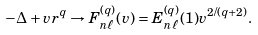<formula> <loc_0><loc_0><loc_500><loc_500>- \Delta + v r ^ { q } \rightarrow F _ { n \ell } ^ { ( q ) } ( v ) = E _ { n \ell } ^ { ( q ) } ( 1 ) v ^ { 2 / ( q + 2 ) } .</formula> 